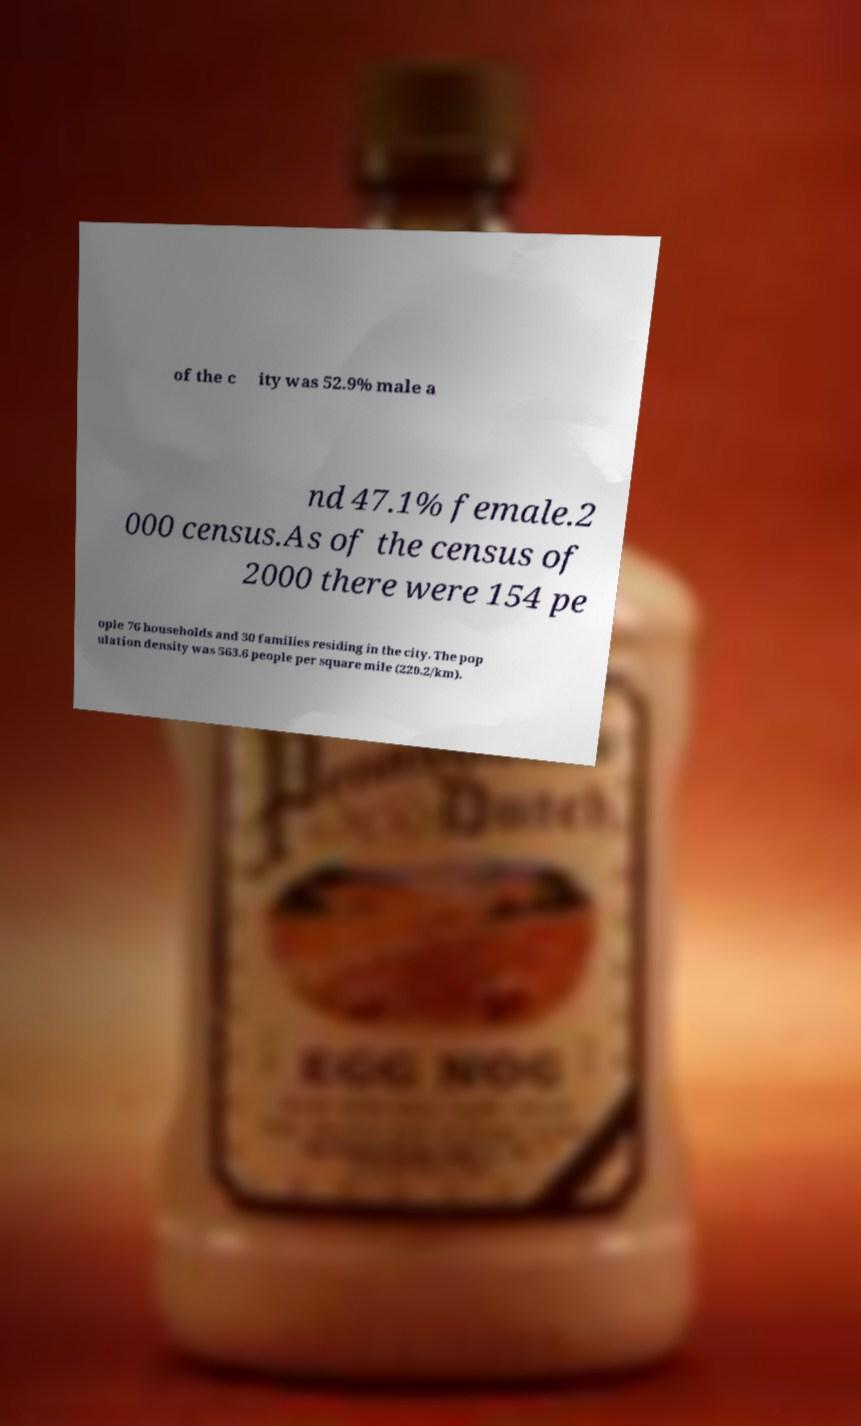Could you extract and type out the text from this image? of the c ity was 52.9% male a nd 47.1% female.2 000 census.As of the census of 2000 there were 154 pe ople 76 households and 30 families residing in the city. The pop ulation density was 563.6 people per square mile (220.2/km). 